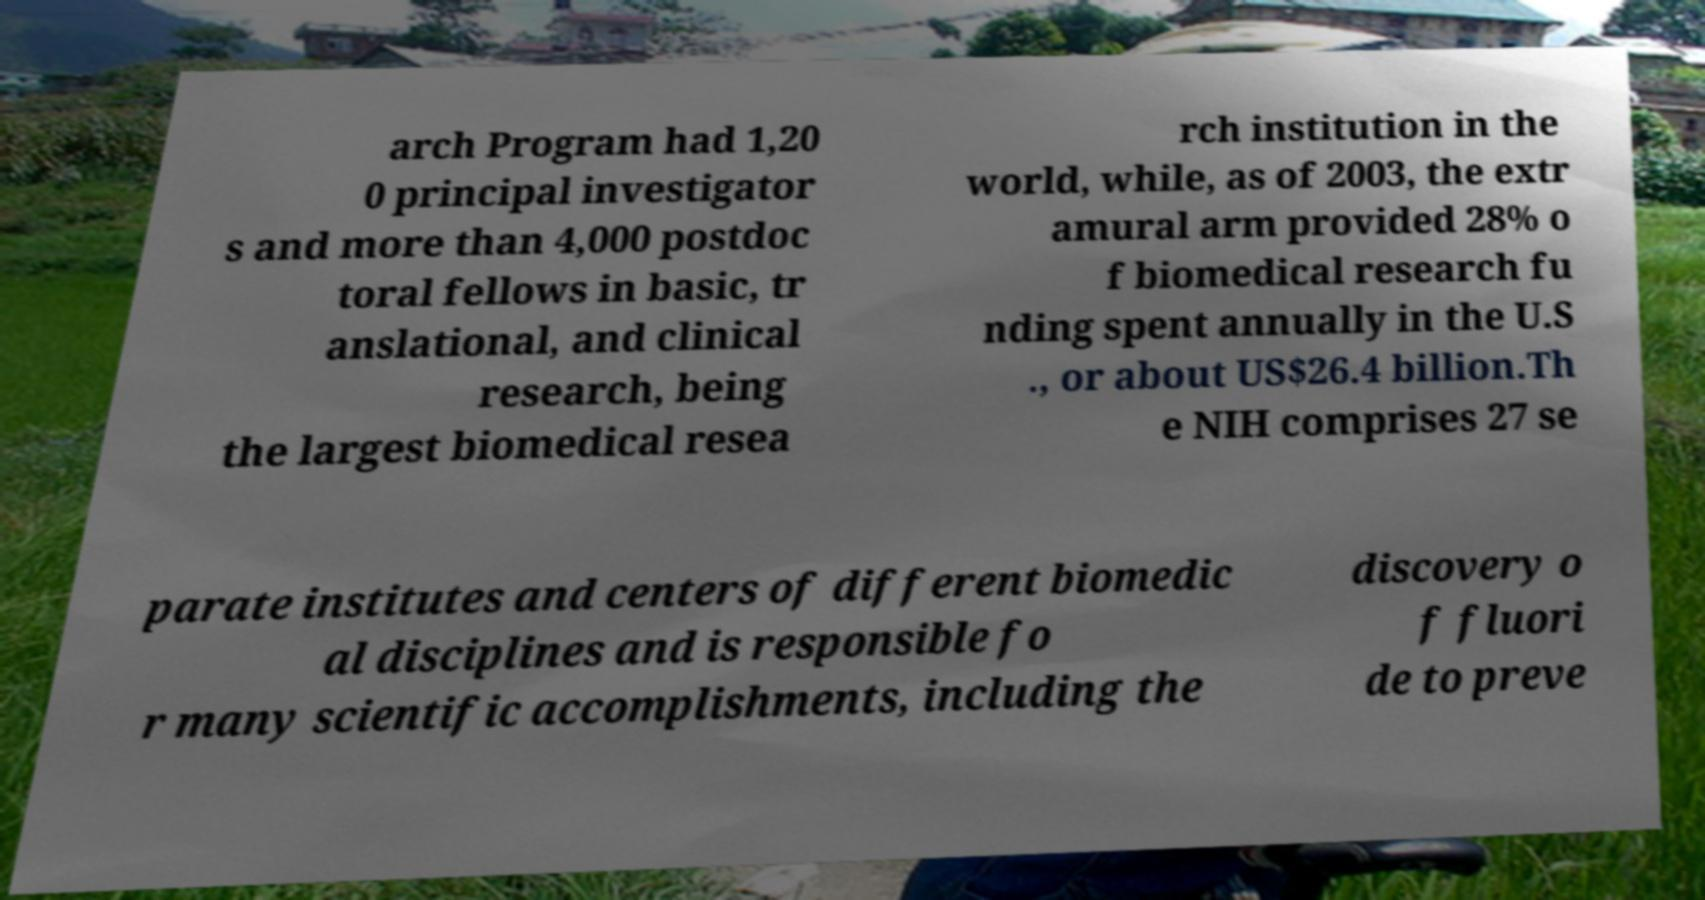Can you read and provide the text displayed in the image?This photo seems to have some interesting text. Can you extract and type it out for me? arch Program had 1,20 0 principal investigator s and more than 4,000 postdoc toral fellows in basic, tr anslational, and clinical research, being the largest biomedical resea rch institution in the world, while, as of 2003, the extr amural arm provided 28% o f biomedical research fu nding spent annually in the U.S ., or about US$26.4 billion.Th e NIH comprises 27 se parate institutes and centers of different biomedic al disciplines and is responsible fo r many scientific accomplishments, including the discovery o f fluori de to preve 